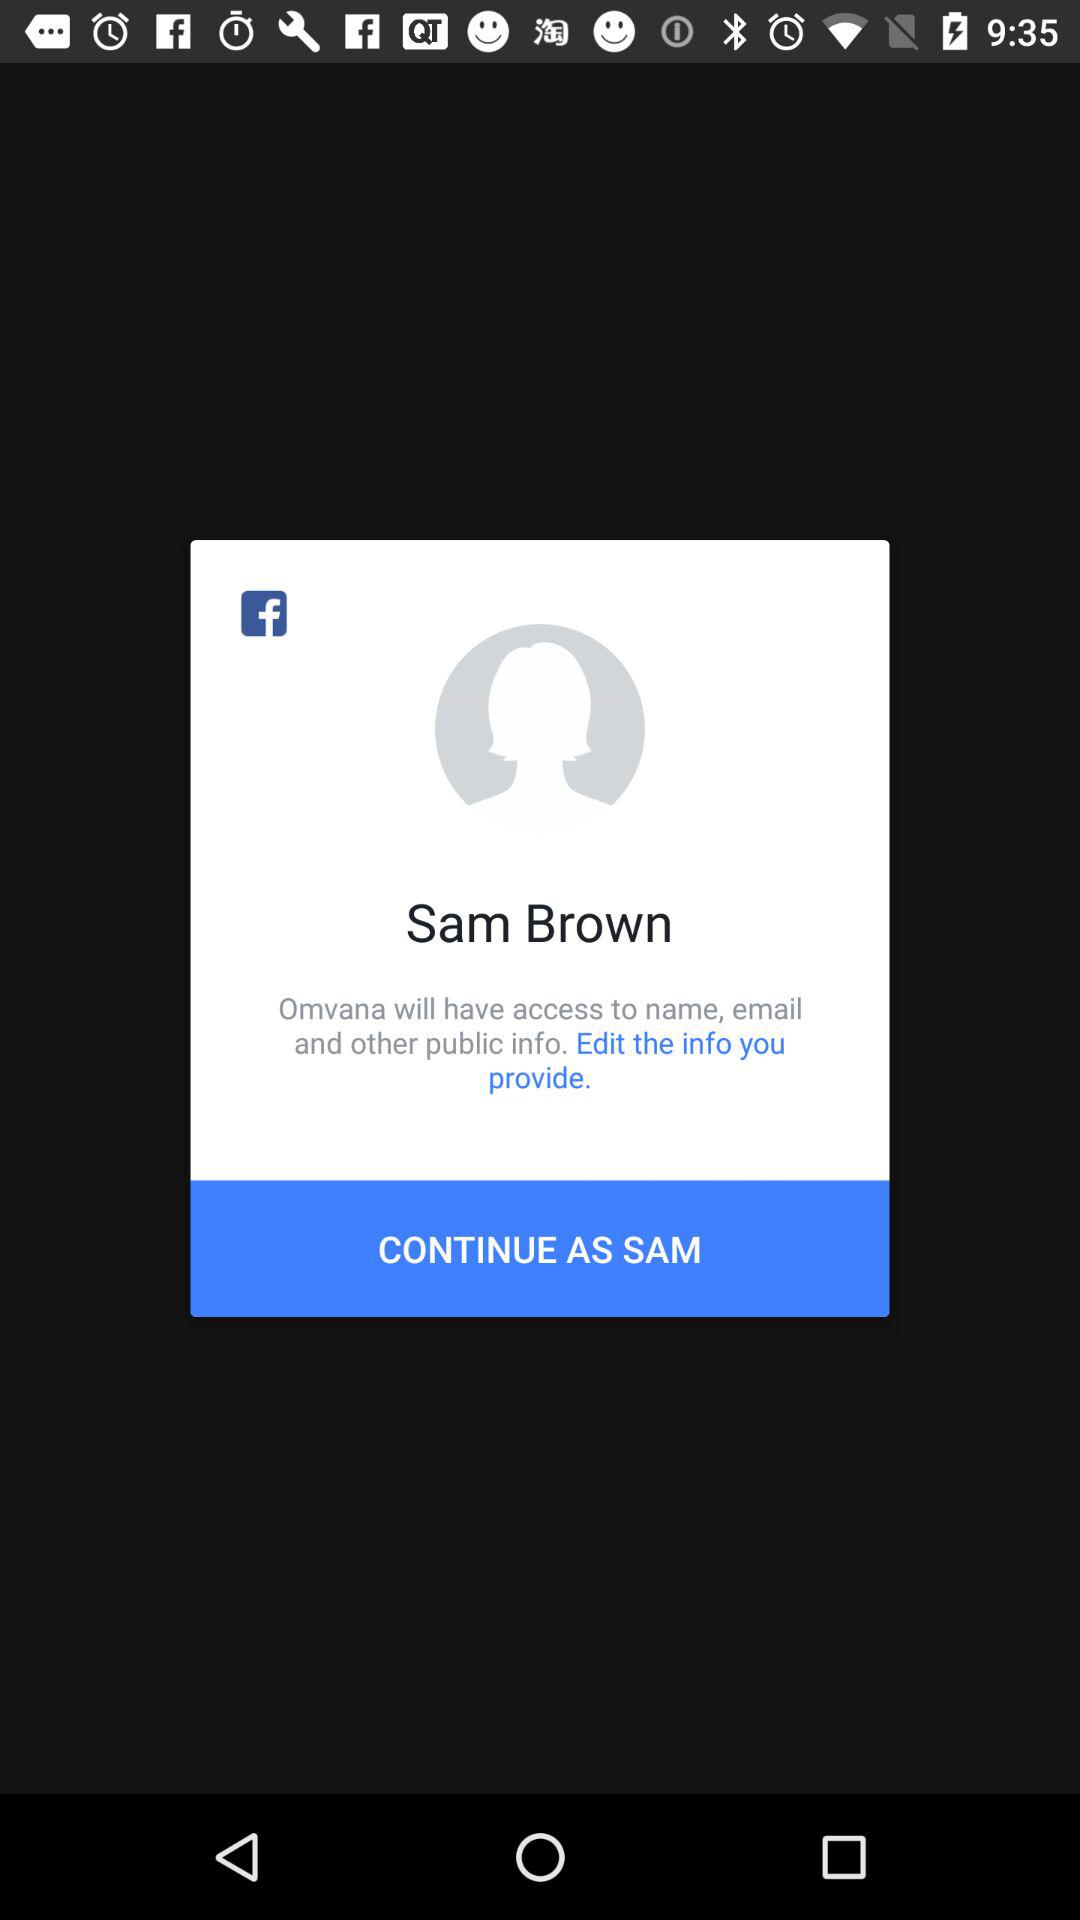Is the provided information edited?
When the provided information is insufficient, respond with <no answer>. <no answer> 